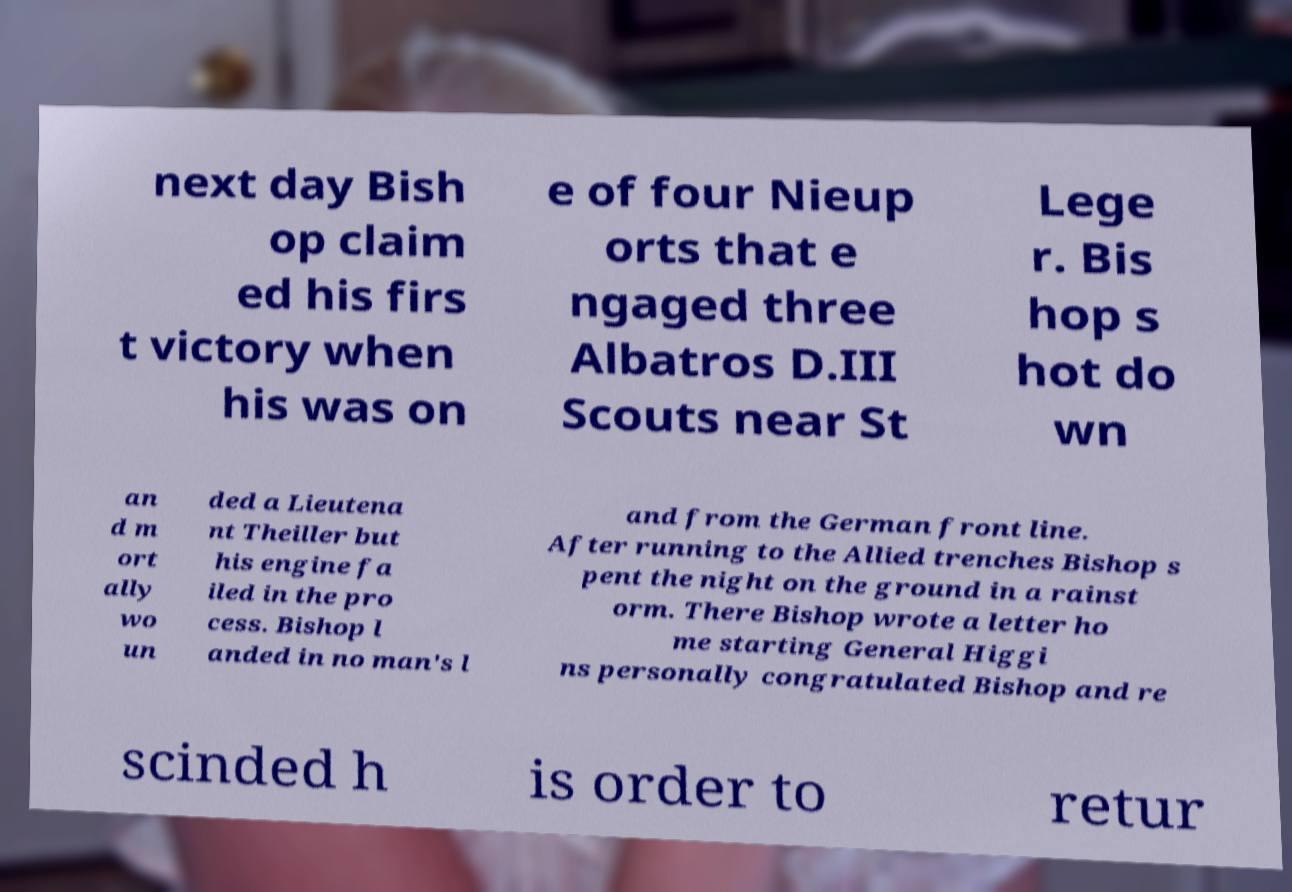For documentation purposes, I need the text within this image transcribed. Could you provide that? next day Bish op claim ed his firs t victory when his was on e of four Nieup orts that e ngaged three Albatros D.III Scouts near St Lege r. Bis hop s hot do wn an d m ort ally wo un ded a Lieutena nt Theiller but his engine fa iled in the pro cess. Bishop l anded in no man's l and from the German front line. After running to the Allied trenches Bishop s pent the night on the ground in a rainst orm. There Bishop wrote a letter ho me starting General Higgi ns personally congratulated Bishop and re scinded h is order to retur 